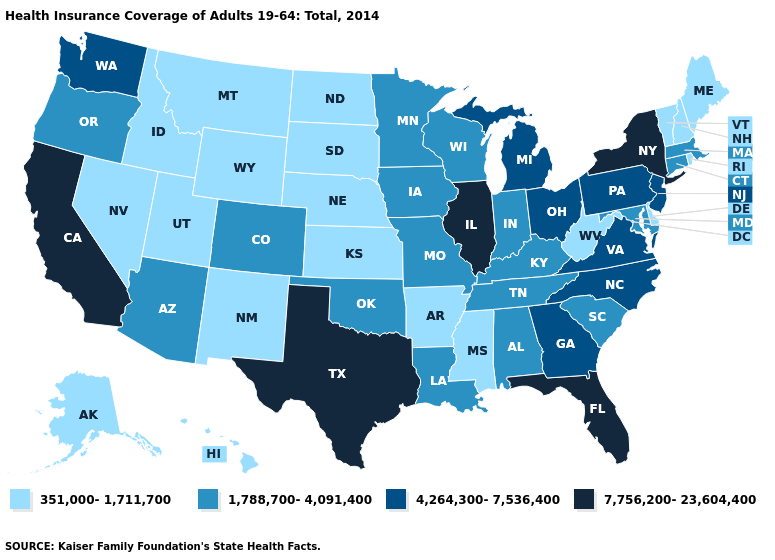Which states have the lowest value in the MidWest?
Keep it brief. Kansas, Nebraska, North Dakota, South Dakota. Name the states that have a value in the range 351,000-1,711,700?
Short answer required. Alaska, Arkansas, Delaware, Hawaii, Idaho, Kansas, Maine, Mississippi, Montana, Nebraska, Nevada, New Hampshire, New Mexico, North Dakota, Rhode Island, South Dakota, Utah, Vermont, West Virginia, Wyoming. Does Kentucky have the same value as Wisconsin?
Quick response, please. Yes. Does Indiana have a higher value than Illinois?
Answer briefly. No. Among the states that border North Carolina , does South Carolina have the lowest value?
Short answer required. Yes. Which states have the lowest value in the South?
Quick response, please. Arkansas, Delaware, Mississippi, West Virginia. Name the states that have a value in the range 1,788,700-4,091,400?
Give a very brief answer. Alabama, Arizona, Colorado, Connecticut, Indiana, Iowa, Kentucky, Louisiana, Maryland, Massachusetts, Minnesota, Missouri, Oklahoma, Oregon, South Carolina, Tennessee, Wisconsin. Does Kentucky have the same value as Indiana?
Short answer required. Yes. Name the states that have a value in the range 1,788,700-4,091,400?
Quick response, please. Alabama, Arizona, Colorado, Connecticut, Indiana, Iowa, Kentucky, Louisiana, Maryland, Massachusetts, Minnesota, Missouri, Oklahoma, Oregon, South Carolina, Tennessee, Wisconsin. What is the value of Kentucky?
Concise answer only. 1,788,700-4,091,400. Which states have the highest value in the USA?
Short answer required. California, Florida, Illinois, New York, Texas. Name the states that have a value in the range 4,264,300-7,536,400?
Answer briefly. Georgia, Michigan, New Jersey, North Carolina, Ohio, Pennsylvania, Virginia, Washington. Does Maryland have the lowest value in the USA?
Keep it brief. No. Which states have the lowest value in the South?
Short answer required. Arkansas, Delaware, Mississippi, West Virginia. 